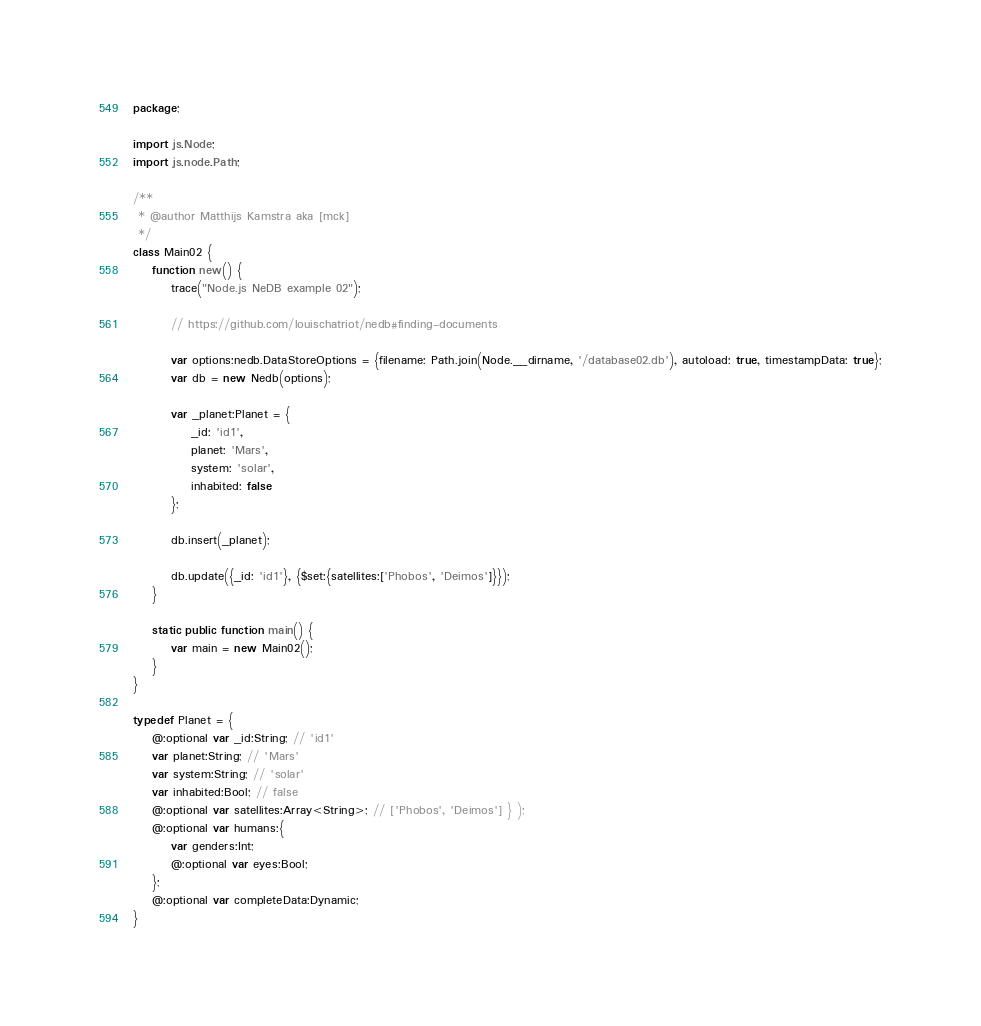<code> <loc_0><loc_0><loc_500><loc_500><_Haxe_>package;

import js.Node;
import js.node.Path;

/**
 * @author Matthijs Kamstra aka [mck]
 */
class Main02 {
	function new() {
		trace("Node.js NeDB example 02");

		// https://github.com/louischatriot/nedb#finding-documents

		var options:nedb.DataStoreOptions = {filename: Path.join(Node.__dirname, '/database02.db'), autoload: true, timestampData: true};
		var db = new Nedb(options);

		var _planet:Planet = {
			_id: 'id1',
			planet: 'Mars',
			system: 'solar',
			inhabited: false
		};

		db.insert(_planet);

		db.update({_id: 'id1'}, {$set:{satellites:['Phobos', 'Deimos']}});
	}

	static public function main() {
		var main = new Main02();
	}
}

typedef Planet = {
	@:optional var _id:String; // 'id1'
	var planet:String; // 'Mars'
	var system:String; // 'solar'
	var inhabited:Bool; // false
	@:optional var satellites:Array<String>; // ['Phobos', 'Deimos'] } );
	@:optional var humans:{
		var genders:Int;
		@:optional var eyes:Bool;
	};
	@:optional var completeData:Dynamic;
}
</code> 